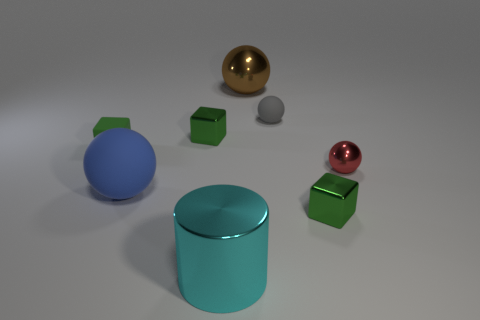Subtract all green cubes. How many were subtracted if there are1green cubes left? 2 Subtract all gray spheres. How many spheres are left? 3 Subtract all big brown shiny balls. How many balls are left? 3 Add 2 blocks. How many objects exist? 10 Subtract all purple balls. Subtract all yellow cylinders. How many balls are left? 4 Subtract all blocks. How many objects are left? 5 Add 6 red metallic objects. How many red metallic objects are left? 7 Add 7 blue balls. How many blue balls exist? 8 Subtract 0 purple cylinders. How many objects are left? 8 Subtract all tiny green shiny things. Subtract all tiny metal blocks. How many objects are left? 4 